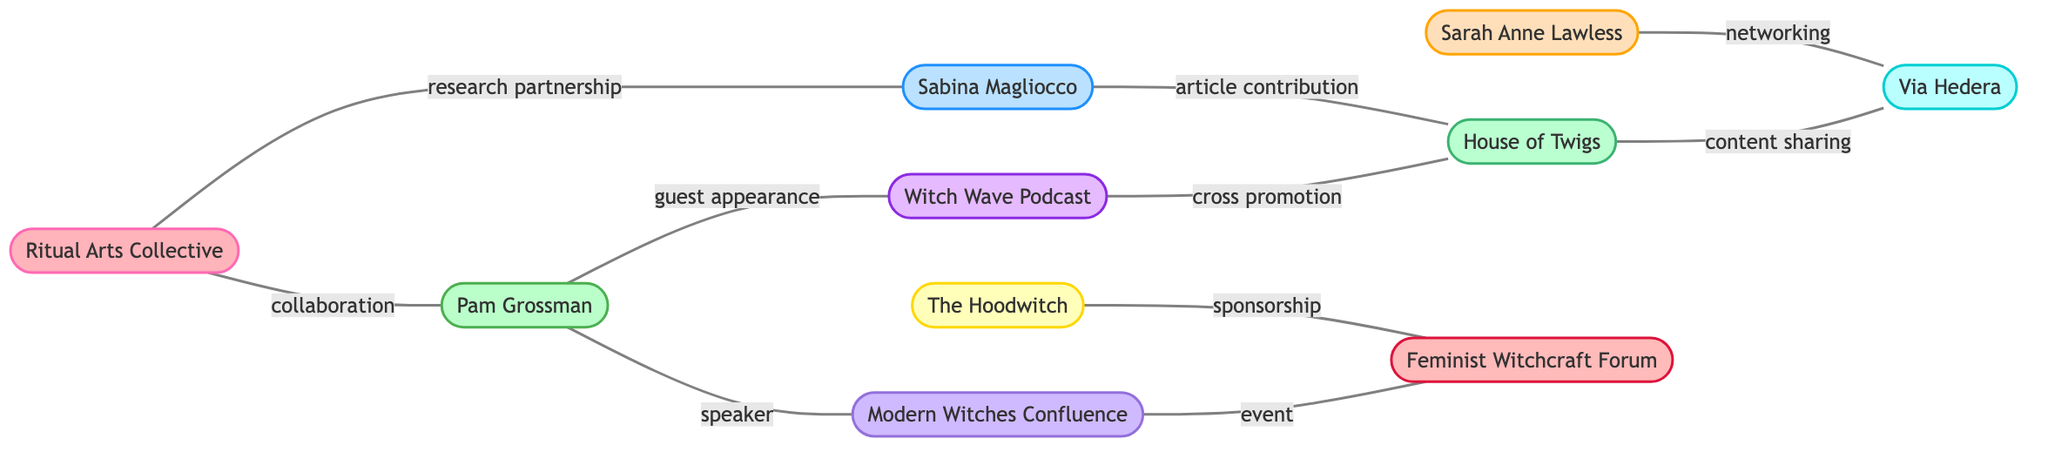What is the total number of nodes in the diagram? Counting the number of nodes listed in the data provided, there are ten nodes representing different entities within the feminist witch movements.
Answer: 10 Who collaborates with the Ritual Arts Collective? The data shows two specific relationships indicating collaboration: Pam Grossman and Sabina Magliocco, both are directly connected to the Ritual Arts Collective by the collaboration and research partnership edges, respectively.
Answer: Pam Grossman, Sabina Magliocco Which type of entity is the Hoodwitch? Referring to the node definitions, the Hoodwitch is categorized as an online platform based on its label and type description.
Answer: online platform What type of relationship exists between the Witch Wave Podcast and House of Twigs? Analyzing the edges, the relationship between the Witch Wave Podcast and House of Twigs is defined by cross promotion, showing a mutual interest in shared content or audience.
Answer: cross promotion How many edges are associated with the Feminist Witchcraft Forum? Evaluating the connections from the nodes, the Feminist Witchcraft Forum has three edges associated with it: one for sponsorship from The Hoodwitch, one for an event connection with Modern Witches Confluence, and one for its engagement with Ritual Arts Collective.
Answer: 3 Which author has a guest appearance on the Witch Wave Podcast? The edges indicate that Pam Grossman is linked to the Witch Wave Podcast by a guest appearance, directly connecting her to that specific media entity.
Answer: Pam Grossman Which organizations are part of content sharing? Looking at the connections, content sharing is noted as the relationship that exists between the House of Twigs and Via Hedera, which indicates these entities actively engage in sharing materials  with each other.
Answer: House of Twigs, Via Hedera How many conference-related nodes are present in the diagram? Upon examining the nodes, there is one node categorized as a conference, which is the Modern Witches Confluence, highlighting its role as a significant event within the network.
Answer: 1 What type of entity is Sabina Magliocco? Based on the definitions provided in the nodes, Sabina Magliocco is classified as an academic, emphasizing her scholarly contributions to the feminist witch movements.
Answer: academic 